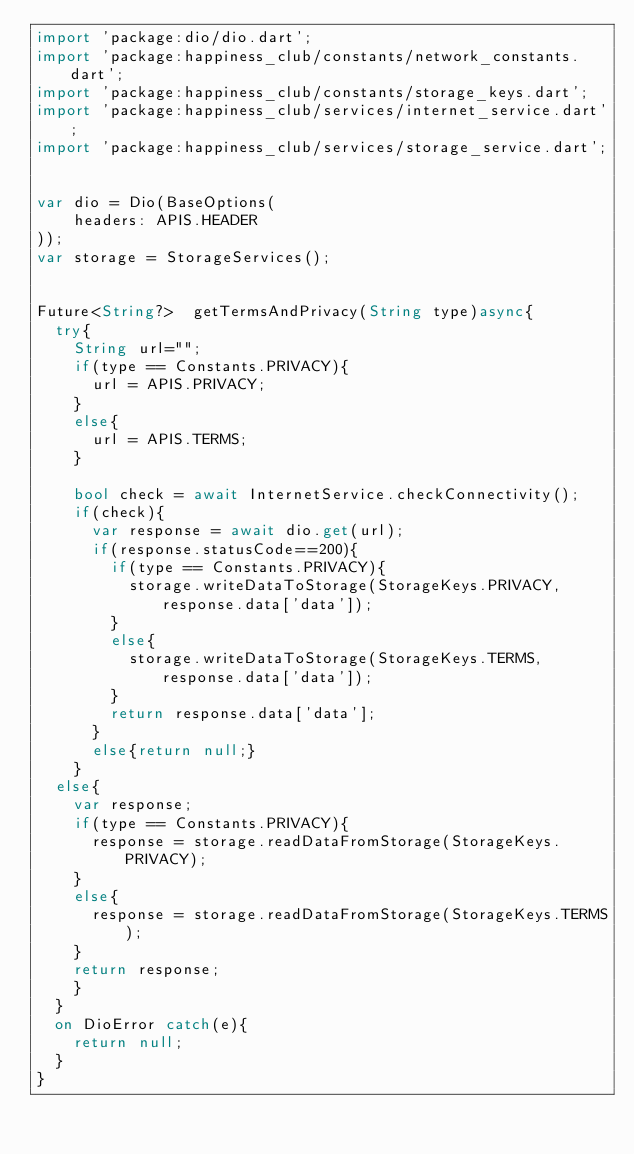Convert code to text. <code><loc_0><loc_0><loc_500><loc_500><_Dart_>import 'package:dio/dio.dart';
import 'package:happiness_club/constants/network_constants.dart';
import 'package:happiness_club/constants/storage_keys.dart';
import 'package:happiness_club/services/internet_service.dart';
import 'package:happiness_club/services/storage_service.dart';


var dio = Dio(BaseOptions(
    headers: APIS.HEADER
));
var storage = StorageServices();


Future<String?>  getTermsAndPrivacy(String type)async{
  try{
    String url="";
    if(type == Constants.PRIVACY){
      url = APIS.PRIVACY;
    }
    else{
      url = APIS.TERMS;
    }

    bool check = await InternetService.checkConnectivity();
    if(check){
      var response = await dio.get(url);
      if(response.statusCode==200){
        if(type == Constants.PRIVACY){
          storage.writeDataToStorage(StorageKeys.PRIVACY, response.data['data']);
        }
        else{
          storage.writeDataToStorage(StorageKeys.TERMS, response.data['data']);
        }
        return response.data['data'];
      }
      else{return null;}
    }
  else{
    var response;
    if(type == Constants.PRIVACY){
      response = storage.readDataFromStorage(StorageKeys.PRIVACY);
    }
    else{
      response = storage.readDataFromStorage(StorageKeys.TERMS);
    }
    return response;
    }
  }
  on DioError catch(e){
    return null;
  }
}</code> 